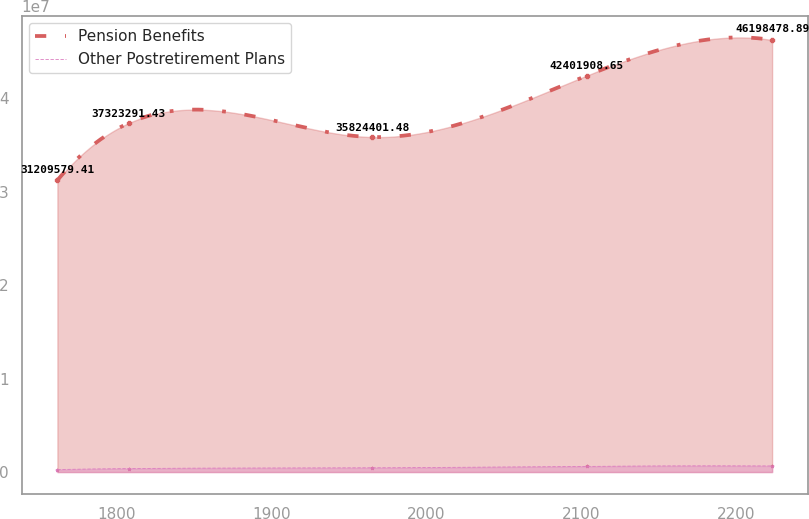Convert chart. <chart><loc_0><loc_0><loc_500><loc_500><line_chart><ecel><fcel>Pension Benefits<fcel>Other Postretirement Plans<nl><fcel>1761.76<fcel>3.12096e+07<fcel>268194<nl><fcel>1807.93<fcel>3.73233e+07<fcel>372013<nl><fcel>1965.22<fcel>3.58244e+07<fcel>452433<nl><fcel>2103.83<fcel>4.24019e+07<fcel>611755<nl><fcel>2223.46<fcel>4.61985e+07<fcel>649751<nl></chart> 